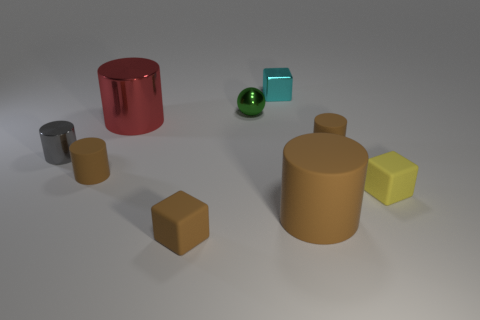The red object that is the same material as the cyan cube is what size?
Make the answer very short. Large. There is a large thing that is behind the shiny thing that is in front of the tiny brown object that is behind the tiny gray metal thing; what is it made of?
Give a very brief answer. Metal. Is the number of large red cylinders less than the number of big green matte cubes?
Your answer should be compact. No. Are the small yellow object and the green thing made of the same material?
Keep it short and to the point. No. Do the small block behind the tiny yellow matte block and the tiny shiny cylinder have the same color?
Keep it short and to the point. No. How many tiny rubber objects are to the left of the rubber object that is left of the large red cylinder?
Your answer should be very brief. 0. What is the color of the shiny cylinder that is the same size as the ball?
Your answer should be compact. Gray. There is a tiny brown object left of the large metal object; what is its material?
Offer a very short reply. Rubber. There is a small cube that is both left of the big brown matte cylinder and on the right side of the tiny shiny sphere; what is it made of?
Give a very brief answer. Metal. Does the matte block that is to the left of the yellow matte cube have the same size as the big red object?
Your response must be concise. No. 